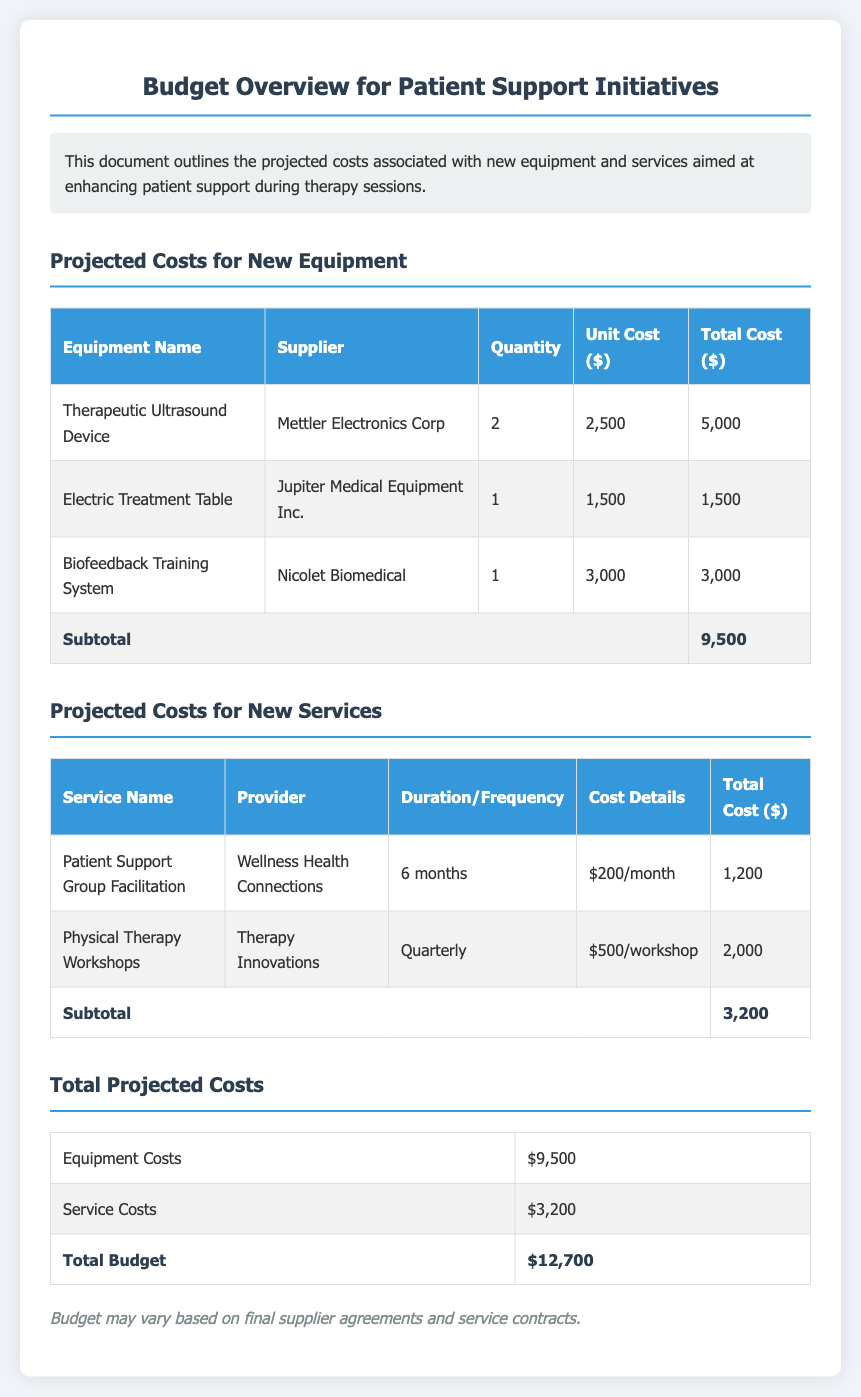What is the total projected budget? The total projected budget is calculated by adding the equipment costs and service costs: $9,500 + $3,200 = $12,700.
Answer: $12,700 How many Electric Treatment Tables are being purchased? The quantity of Electric Treatment Tables can be found in the equipment table, where it states that 1 unit is being purchased.
Answer: 1 What is the unit cost of the Therapeutic Ultrasound Device? The unit cost for the Therapeutic Ultrasound Device is listed in the table as $2,500.
Answer: $2,500 What is the total cost for Physical Therapy Workshops? The total cost for Physical Therapy Workshops is found in the services table, which indicates a total of $2,000.
Answer: $2,000 Who is the supplier for the Biofeedback Training System? The supplier for the Biofeedback Training System is specified as Nicolet Biomedical in the equipment table.
Answer: Nicolet Biomedical What is the subtotal for equipment costs? The subtotal for equipment costs is provided at the end of the equipment table, summing up to $9,500.
Answer: $9,500 How long is the Patient Support Group Facilitation service offered? The duration for the Patient Support Group Facilitation service is specified as 6 months.
Answer: 6 months What is the method in which Physical Therapy Workshops are scheduled? The Physical Therapy Workshops are scheduled quarterly, as stated in the services table.
Answer: Quarterly What color is used for the subtotal rows in the tables? The subtotal rows in the tables are typically highlighted with a distinct bold font for emphasis but maintain the standard background color.
Answer: Bold 